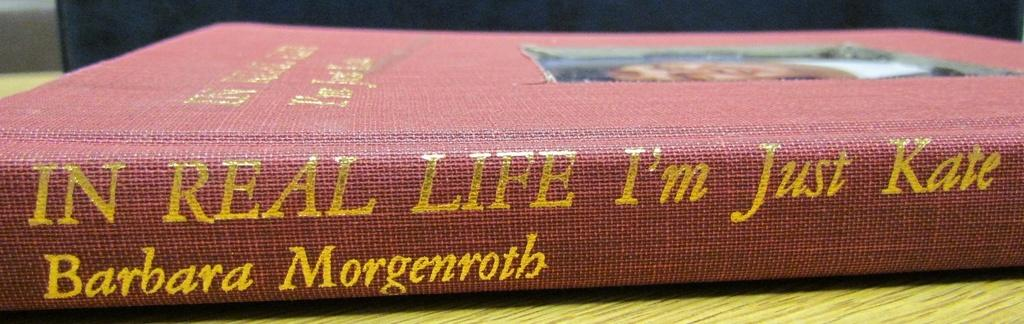<image>
Write a terse but informative summary of the picture. Barbara Morgenroth wrote a story titled In Real Life I'm Just Kate 